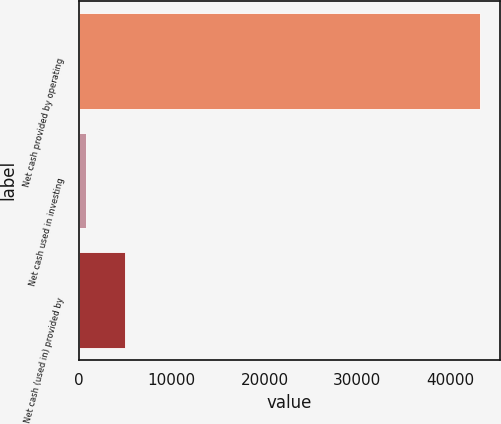Convert chart. <chart><loc_0><loc_0><loc_500><loc_500><bar_chart><fcel>Net cash provided by operating<fcel>Net cash used in investing<fcel>Net cash (used in) provided by<nl><fcel>43229<fcel>711<fcel>4962.8<nl></chart> 